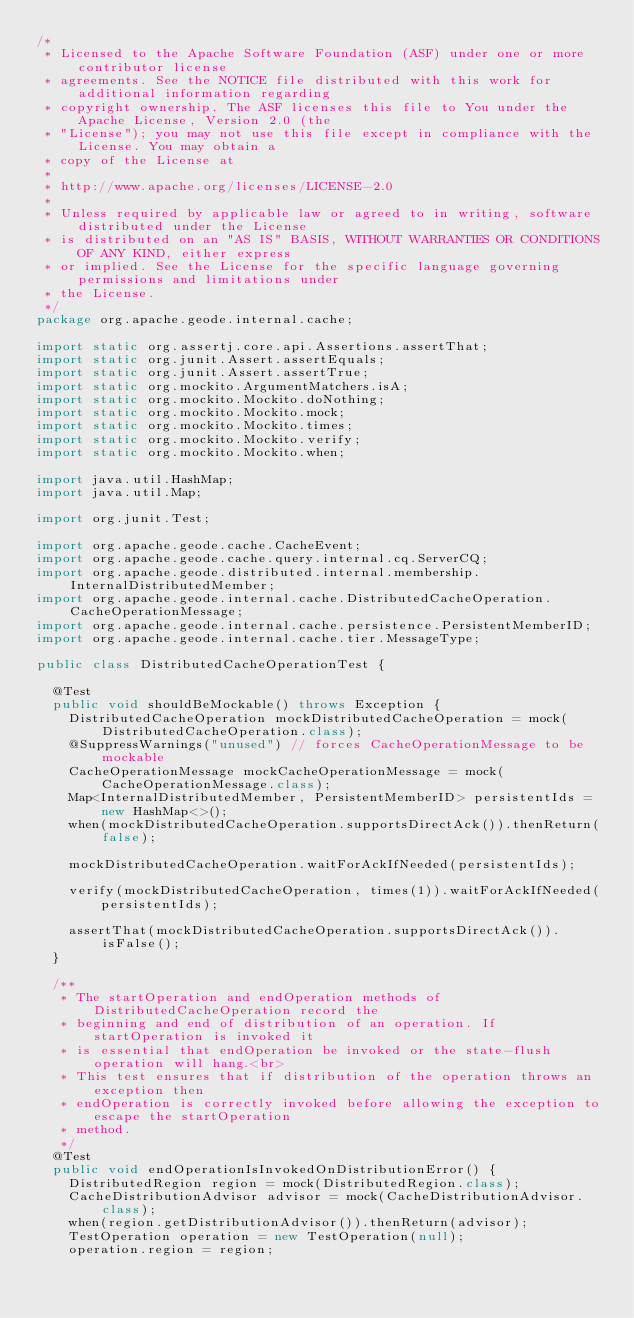Convert code to text. <code><loc_0><loc_0><loc_500><loc_500><_Java_>/*
 * Licensed to the Apache Software Foundation (ASF) under one or more contributor license
 * agreements. See the NOTICE file distributed with this work for additional information regarding
 * copyright ownership. The ASF licenses this file to You under the Apache License, Version 2.0 (the
 * "License"); you may not use this file except in compliance with the License. You may obtain a
 * copy of the License at
 *
 * http://www.apache.org/licenses/LICENSE-2.0
 *
 * Unless required by applicable law or agreed to in writing, software distributed under the License
 * is distributed on an "AS IS" BASIS, WITHOUT WARRANTIES OR CONDITIONS OF ANY KIND, either express
 * or implied. See the License for the specific language governing permissions and limitations under
 * the License.
 */
package org.apache.geode.internal.cache;

import static org.assertj.core.api.Assertions.assertThat;
import static org.junit.Assert.assertEquals;
import static org.junit.Assert.assertTrue;
import static org.mockito.ArgumentMatchers.isA;
import static org.mockito.Mockito.doNothing;
import static org.mockito.Mockito.mock;
import static org.mockito.Mockito.times;
import static org.mockito.Mockito.verify;
import static org.mockito.Mockito.when;

import java.util.HashMap;
import java.util.Map;

import org.junit.Test;

import org.apache.geode.cache.CacheEvent;
import org.apache.geode.cache.query.internal.cq.ServerCQ;
import org.apache.geode.distributed.internal.membership.InternalDistributedMember;
import org.apache.geode.internal.cache.DistributedCacheOperation.CacheOperationMessage;
import org.apache.geode.internal.cache.persistence.PersistentMemberID;
import org.apache.geode.internal.cache.tier.MessageType;

public class DistributedCacheOperationTest {

  @Test
  public void shouldBeMockable() throws Exception {
    DistributedCacheOperation mockDistributedCacheOperation = mock(DistributedCacheOperation.class);
    @SuppressWarnings("unused") // forces CacheOperationMessage to be mockable
    CacheOperationMessage mockCacheOperationMessage = mock(CacheOperationMessage.class);
    Map<InternalDistributedMember, PersistentMemberID> persistentIds = new HashMap<>();
    when(mockDistributedCacheOperation.supportsDirectAck()).thenReturn(false);

    mockDistributedCacheOperation.waitForAckIfNeeded(persistentIds);

    verify(mockDistributedCacheOperation, times(1)).waitForAckIfNeeded(
        persistentIds);

    assertThat(mockDistributedCacheOperation.supportsDirectAck()).isFalse();
  }

  /**
   * The startOperation and endOperation methods of DistributedCacheOperation record the
   * beginning and end of distribution of an operation. If startOperation is invoked it
   * is essential that endOperation be invoked or the state-flush operation will hang.<br>
   * This test ensures that if distribution of the operation throws an exception then
   * endOperation is correctly invoked before allowing the exception to escape the startOperation
   * method.
   */
  @Test
  public void endOperationIsInvokedOnDistributionError() {
    DistributedRegion region = mock(DistributedRegion.class);
    CacheDistributionAdvisor advisor = mock(CacheDistributionAdvisor.class);
    when(region.getDistributionAdvisor()).thenReturn(advisor);
    TestOperation operation = new TestOperation(null);
    operation.region = region;</code> 